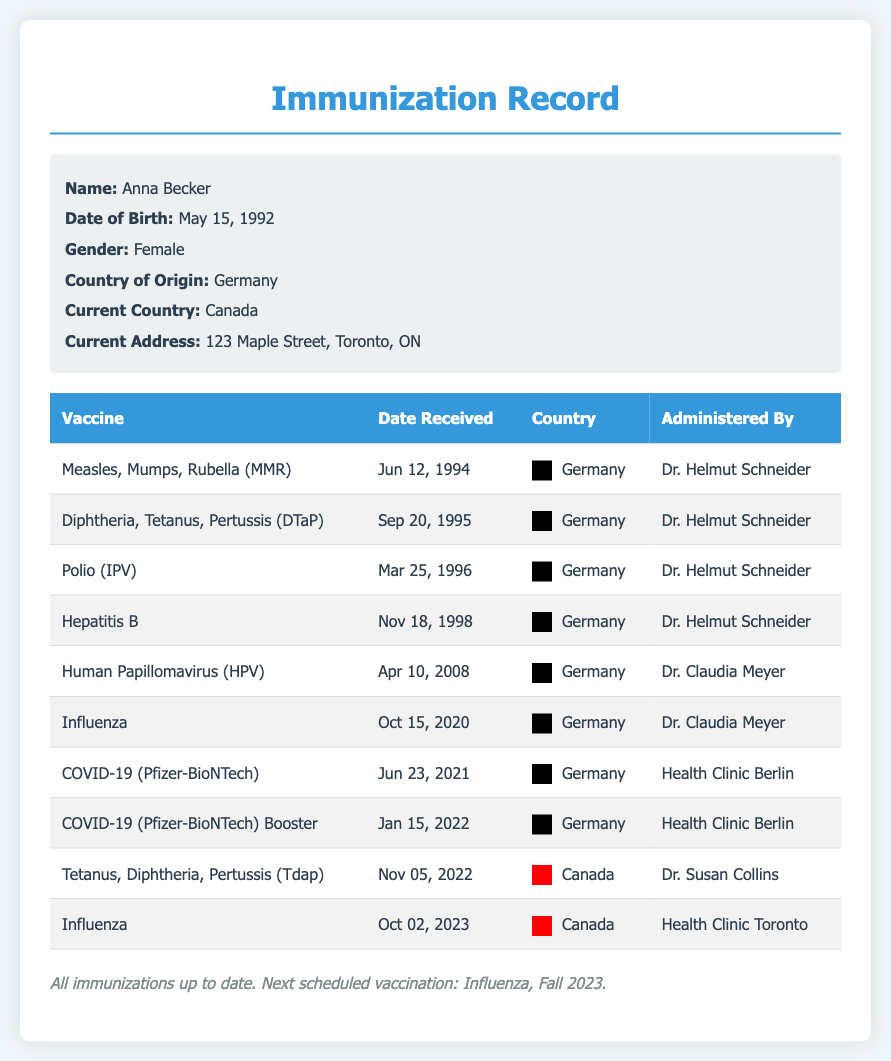what is the name of the patient? The patient's name is listed at the top of the document in the personal info section as Anna Becker.
Answer: Anna Becker when was the first vaccination received? The first vaccination date is found in the table under "Date Received" for the "Measles, Mumps, Rubella (MMR)" vaccine.
Answer: Jun 12, 1994 how many COVID-19 vaccines were received in Germany? The number of COVID-19 vaccines can be found by counting the entries in the table under Germany for the COVID-19 vaccine.
Answer: 2 who administered the Tdap vaccine? The administrating doctor's name for the Tdap vaccine is stated in the corresponding row in the document.
Answer: Dr. Susan Collins what was the last vaccine received? The most recent vaccine date is indicated by the last entry in the table.
Answer: Influenza how many vaccines were administered in Canada? The count of entries for vaccines administered in Canada is required from the displayed data in the table.
Answer: 2 which vaccine was received on Oct 02, 2023? The vaccine corresponding to the date Oct 02, 2023, can be found in the table under "Date Received".
Answer: Influenza who administered the HPV vaccine? The name of the doctor who administered the HPV vaccine is specified in the corresponding entry in the document.
Answer: Dr. Claudia Meyer 